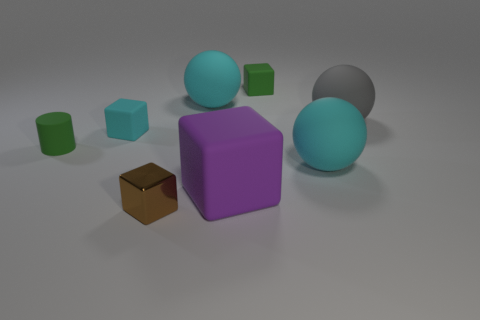Add 1 matte blocks. How many objects exist? 9 Subtract all balls. How many objects are left? 5 Add 1 large cyan rubber spheres. How many large cyan rubber spheres exist? 3 Subtract 0 brown cylinders. How many objects are left? 8 Subtract all small brown things. Subtract all large objects. How many objects are left? 3 Add 2 green matte cylinders. How many green matte cylinders are left? 3 